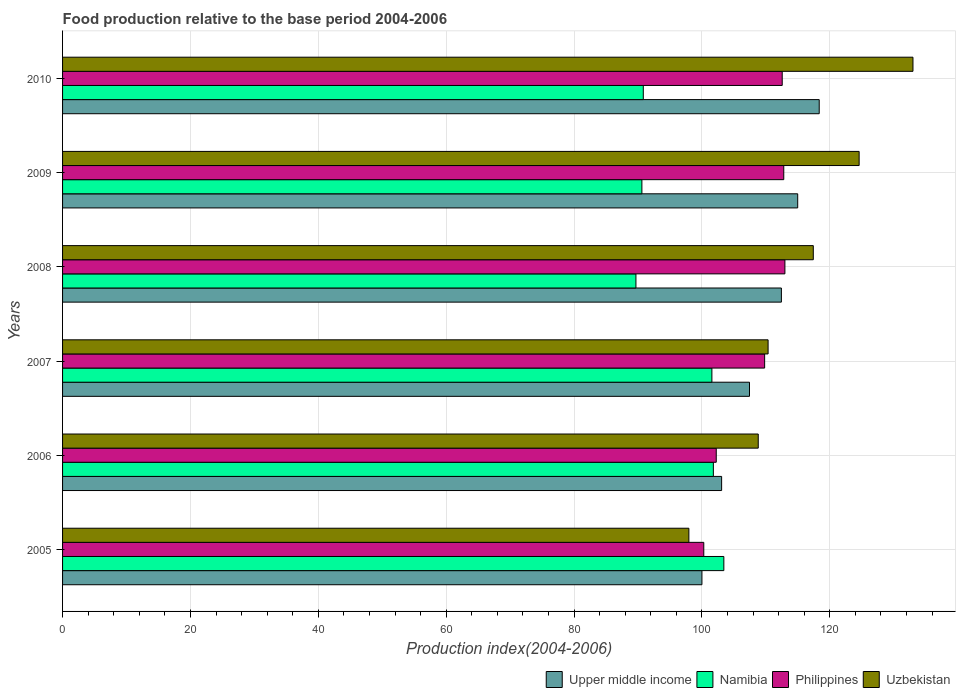How many groups of bars are there?
Make the answer very short. 6. Are the number of bars on each tick of the Y-axis equal?
Offer a terse response. Yes. How many bars are there on the 6th tick from the top?
Provide a short and direct response. 4. What is the food production index in Uzbekistan in 2009?
Provide a short and direct response. 124.59. Across all years, what is the maximum food production index in Philippines?
Your response must be concise. 112.98. Across all years, what is the minimum food production index in Philippines?
Offer a very short reply. 100.29. What is the total food production index in Upper middle income in the graph?
Offer a terse response. 656.28. What is the difference between the food production index in Upper middle income in 2005 and that in 2010?
Ensure brevity in your answer.  -18.35. What is the difference between the food production index in Upper middle income in 2006 and the food production index in Uzbekistan in 2010?
Provide a succinct answer. -29.93. What is the average food production index in Upper middle income per year?
Your answer should be very brief. 109.38. In the year 2010, what is the difference between the food production index in Uzbekistan and food production index in Namibia?
Provide a succinct answer. 42.18. What is the ratio of the food production index in Uzbekistan in 2006 to that in 2007?
Your response must be concise. 0.99. Is the food production index in Namibia in 2008 less than that in 2009?
Your answer should be compact. Yes. What is the difference between the highest and the second highest food production index in Upper middle income?
Your answer should be very brief. 3.37. What is the difference between the highest and the lowest food production index in Philippines?
Give a very brief answer. 12.69. In how many years, is the food production index in Upper middle income greater than the average food production index in Upper middle income taken over all years?
Provide a succinct answer. 3. What does the 3rd bar from the top in 2008 represents?
Provide a succinct answer. Namibia. What does the 4th bar from the bottom in 2009 represents?
Provide a succinct answer. Uzbekistan. How many bars are there?
Make the answer very short. 24. Are all the bars in the graph horizontal?
Offer a very short reply. Yes. What is the difference between two consecutive major ticks on the X-axis?
Give a very brief answer. 20. Are the values on the major ticks of X-axis written in scientific E-notation?
Ensure brevity in your answer.  No. Does the graph contain any zero values?
Your response must be concise. No. How are the legend labels stacked?
Offer a very short reply. Horizontal. What is the title of the graph?
Keep it short and to the point. Food production relative to the base period 2004-2006. Does "Chad" appear as one of the legend labels in the graph?
Provide a succinct answer. No. What is the label or title of the X-axis?
Provide a short and direct response. Production index(2004-2006). What is the label or title of the Y-axis?
Provide a short and direct response. Years. What is the Production index(2004-2006) in Upper middle income in 2005?
Your response must be concise. 100. What is the Production index(2004-2006) of Namibia in 2005?
Offer a very short reply. 103.43. What is the Production index(2004-2006) in Philippines in 2005?
Provide a short and direct response. 100.29. What is the Production index(2004-2006) of Uzbekistan in 2005?
Provide a succinct answer. 97.96. What is the Production index(2004-2006) of Upper middle income in 2006?
Keep it short and to the point. 103.08. What is the Production index(2004-2006) of Namibia in 2006?
Ensure brevity in your answer.  101.79. What is the Production index(2004-2006) in Philippines in 2006?
Your response must be concise. 102.24. What is the Production index(2004-2006) of Uzbekistan in 2006?
Give a very brief answer. 108.81. What is the Production index(2004-2006) in Upper middle income in 2007?
Your answer should be very brief. 107.44. What is the Production index(2004-2006) of Namibia in 2007?
Offer a terse response. 101.56. What is the Production index(2004-2006) of Philippines in 2007?
Your response must be concise. 109.81. What is the Production index(2004-2006) in Uzbekistan in 2007?
Your answer should be very brief. 110.35. What is the Production index(2004-2006) of Upper middle income in 2008?
Your answer should be compact. 112.43. What is the Production index(2004-2006) in Namibia in 2008?
Ensure brevity in your answer.  89.68. What is the Production index(2004-2006) of Philippines in 2008?
Provide a short and direct response. 112.98. What is the Production index(2004-2006) of Uzbekistan in 2008?
Give a very brief answer. 117.42. What is the Production index(2004-2006) of Upper middle income in 2009?
Make the answer very short. 114.98. What is the Production index(2004-2006) of Namibia in 2009?
Your answer should be very brief. 90.61. What is the Production index(2004-2006) in Philippines in 2009?
Make the answer very short. 112.8. What is the Production index(2004-2006) of Uzbekistan in 2009?
Offer a very short reply. 124.59. What is the Production index(2004-2006) of Upper middle income in 2010?
Provide a succinct answer. 118.35. What is the Production index(2004-2006) of Namibia in 2010?
Ensure brevity in your answer.  90.83. What is the Production index(2004-2006) in Philippines in 2010?
Your answer should be very brief. 112.56. What is the Production index(2004-2006) of Uzbekistan in 2010?
Your answer should be compact. 133.01. Across all years, what is the maximum Production index(2004-2006) of Upper middle income?
Provide a short and direct response. 118.35. Across all years, what is the maximum Production index(2004-2006) in Namibia?
Give a very brief answer. 103.43. Across all years, what is the maximum Production index(2004-2006) of Philippines?
Provide a short and direct response. 112.98. Across all years, what is the maximum Production index(2004-2006) of Uzbekistan?
Your response must be concise. 133.01. Across all years, what is the minimum Production index(2004-2006) in Upper middle income?
Provide a succinct answer. 100. Across all years, what is the minimum Production index(2004-2006) in Namibia?
Give a very brief answer. 89.68. Across all years, what is the minimum Production index(2004-2006) in Philippines?
Your response must be concise. 100.29. Across all years, what is the minimum Production index(2004-2006) in Uzbekistan?
Ensure brevity in your answer.  97.96. What is the total Production index(2004-2006) in Upper middle income in the graph?
Provide a succinct answer. 656.28. What is the total Production index(2004-2006) in Namibia in the graph?
Offer a very short reply. 577.9. What is the total Production index(2004-2006) of Philippines in the graph?
Offer a terse response. 650.68. What is the total Production index(2004-2006) of Uzbekistan in the graph?
Give a very brief answer. 692.14. What is the difference between the Production index(2004-2006) of Upper middle income in 2005 and that in 2006?
Your answer should be compact. -3.08. What is the difference between the Production index(2004-2006) of Namibia in 2005 and that in 2006?
Provide a short and direct response. 1.64. What is the difference between the Production index(2004-2006) of Philippines in 2005 and that in 2006?
Keep it short and to the point. -1.95. What is the difference between the Production index(2004-2006) of Uzbekistan in 2005 and that in 2006?
Give a very brief answer. -10.85. What is the difference between the Production index(2004-2006) in Upper middle income in 2005 and that in 2007?
Provide a short and direct response. -7.44. What is the difference between the Production index(2004-2006) of Namibia in 2005 and that in 2007?
Provide a succinct answer. 1.87. What is the difference between the Production index(2004-2006) of Philippines in 2005 and that in 2007?
Ensure brevity in your answer.  -9.52. What is the difference between the Production index(2004-2006) of Uzbekistan in 2005 and that in 2007?
Keep it short and to the point. -12.39. What is the difference between the Production index(2004-2006) of Upper middle income in 2005 and that in 2008?
Your response must be concise. -12.43. What is the difference between the Production index(2004-2006) of Namibia in 2005 and that in 2008?
Provide a short and direct response. 13.75. What is the difference between the Production index(2004-2006) of Philippines in 2005 and that in 2008?
Give a very brief answer. -12.69. What is the difference between the Production index(2004-2006) in Uzbekistan in 2005 and that in 2008?
Ensure brevity in your answer.  -19.46. What is the difference between the Production index(2004-2006) of Upper middle income in 2005 and that in 2009?
Provide a short and direct response. -14.98. What is the difference between the Production index(2004-2006) in Namibia in 2005 and that in 2009?
Make the answer very short. 12.82. What is the difference between the Production index(2004-2006) of Philippines in 2005 and that in 2009?
Keep it short and to the point. -12.51. What is the difference between the Production index(2004-2006) in Uzbekistan in 2005 and that in 2009?
Provide a succinct answer. -26.63. What is the difference between the Production index(2004-2006) of Upper middle income in 2005 and that in 2010?
Provide a succinct answer. -18.34. What is the difference between the Production index(2004-2006) of Philippines in 2005 and that in 2010?
Ensure brevity in your answer.  -12.27. What is the difference between the Production index(2004-2006) of Uzbekistan in 2005 and that in 2010?
Offer a terse response. -35.05. What is the difference between the Production index(2004-2006) of Upper middle income in 2006 and that in 2007?
Make the answer very short. -4.36. What is the difference between the Production index(2004-2006) in Namibia in 2006 and that in 2007?
Your answer should be very brief. 0.23. What is the difference between the Production index(2004-2006) of Philippines in 2006 and that in 2007?
Your response must be concise. -7.57. What is the difference between the Production index(2004-2006) of Uzbekistan in 2006 and that in 2007?
Your answer should be very brief. -1.54. What is the difference between the Production index(2004-2006) of Upper middle income in 2006 and that in 2008?
Your answer should be very brief. -9.35. What is the difference between the Production index(2004-2006) of Namibia in 2006 and that in 2008?
Give a very brief answer. 12.11. What is the difference between the Production index(2004-2006) of Philippines in 2006 and that in 2008?
Your answer should be compact. -10.74. What is the difference between the Production index(2004-2006) in Uzbekistan in 2006 and that in 2008?
Give a very brief answer. -8.61. What is the difference between the Production index(2004-2006) of Upper middle income in 2006 and that in 2009?
Your response must be concise. -11.9. What is the difference between the Production index(2004-2006) in Namibia in 2006 and that in 2009?
Your response must be concise. 11.18. What is the difference between the Production index(2004-2006) of Philippines in 2006 and that in 2009?
Keep it short and to the point. -10.56. What is the difference between the Production index(2004-2006) in Uzbekistan in 2006 and that in 2009?
Your answer should be very brief. -15.78. What is the difference between the Production index(2004-2006) in Upper middle income in 2006 and that in 2010?
Provide a short and direct response. -15.27. What is the difference between the Production index(2004-2006) in Namibia in 2006 and that in 2010?
Your answer should be very brief. 10.96. What is the difference between the Production index(2004-2006) in Philippines in 2006 and that in 2010?
Provide a succinct answer. -10.32. What is the difference between the Production index(2004-2006) of Uzbekistan in 2006 and that in 2010?
Your answer should be compact. -24.2. What is the difference between the Production index(2004-2006) in Upper middle income in 2007 and that in 2008?
Your answer should be very brief. -4.99. What is the difference between the Production index(2004-2006) in Namibia in 2007 and that in 2008?
Your response must be concise. 11.88. What is the difference between the Production index(2004-2006) in Philippines in 2007 and that in 2008?
Your answer should be very brief. -3.17. What is the difference between the Production index(2004-2006) of Uzbekistan in 2007 and that in 2008?
Your answer should be compact. -7.07. What is the difference between the Production index(2004-2006) of Upper middle income in 2007 and that in 2009?
Offer a very short reply. -7.54. What is the difference between the Production index(2004-2006) in Namibia in 2007 and that in 2009?
Your answer should be very brief. 10.95. What is the difference between the Production index(2004-2006) in Philippines in 2007 and that in 2009?
Ensure brevity in your answer.  -2.99. What is the difference between the Production index(2004-2006) in Uzbekistan in 2007 and that in 2009?
Ensure brevity in your answer.  -14.24. What is the difference between the Production index(2004-2006) of Upper middle income in 2007 and that in 2010?
Ensure brevity in your answer.  -10.91. What is the difference between the Production index(2004-2006) of Namibia in 2007 and that in 2010?
Provide a short and direct response. 10.73. What is the difference between the Production index(2004-2006) of Philippines in 2007 and that in 2010?
Your answer should be compact. -2.75. What is the difference between the Production index(2004-2006) in Uzbekistan in 2007 and that in 2010?
Your response must be concise. -22.66. What is the difference between the Production index(2004-2006) in Upper middle income in 2008 and that in 2009?
Make the answer very short. -2.55. What is the difference between the Production index(2004-2006) of Namibia in 2008 and that in 2009?
Make the answer very short. -0.93. What is the difference between the Production index(2004-2006) in Philippines in 2008 and that in 2009?
Give a very brief answer. 0.18. What is the difference between the Production index(2004-2006) in Uzbekistan in 2008 and that in 2009?
Make the answer very short. -7.17. What is the difference between the Production index(2004-2006) of Upper middle income in 2008 and that in 2010?
Provide a succinct answer. -5.92. What is the difference between the Production index(2004-2006) of Namibia in 2008 and that in 2010?
Give a very brief answer. -1.15. What is the difference between the Production index(2004-2006) of Philippines in 2008 and that in 2010?
Provide a short and direct response. 0.42. What is the difference between the Production index(2004-2006) of Uzbekistan in 2008 and that in 2010?
Offer a terse response. -15.59. What is the difference between the Production index(2004-2006) of Upper middle income in 2009 and that in 2010?
Provide a short and direct response. -3.37. What is the difference between the Production index(2004-2006) in Namibia in 2009 and that in 2010?
Keep it short and to the point. -0.22. What is the difference between the Production index(2004-2006) in Philippines in 2009 and that in 2010?
Your answer should be compact. 0.24. What is the difference between the Production index(2004-2006) in Uzbekistan in 2009 and that in 2010?
Make the answer very short. -8.42. What is the difference between the Production index(2004-2006) of Upper middle income in 2005 and the Production index(2004-2006) of Namibia in 2006?
Keep it short and to the point. -1.79. What is the difference between the Production index(2004-2006) in Upper middle income in 2005 and the Production index(2004-2006) in Philippines in 2006?
Ensure brevity in your answer.  -2.24. What is the difference between the Production index(2004-2006) of Upper middle income in 2005 and the Production index(2004-2006) of Uzbekistan in 2006?
Provide a succinct answer. -8.81. What is the difference between the Production index(2004-2006) in Namibia in 2005 and the Production index(2004-2006) in Philippines in 2006?
Provide a short and direct response. 1.19. What is the difference between the Production index(2004-2006) in Namibia in 2005 and the Production index(2004-2006) in Uzbekistan in 2006?
Offer a very short reply. -5.38. What is the difference between the Production index(2004-2006) of Philippines in 2005 and the Production index(2004-2006) of Uzbekistan in 2006?
Keep it short and to the point. -8.52. What is the difference between the Production index(2004-2006) in Upper middle income in 2005 and the Production index(2004-2006) in Namibia in 2007?
Provide a succinct answer. -1.56. What is the difference between the Production index(2004-2006) in Upper middle income in 2005 and the Production index(2004-2006) in Philippines in 2007?
Give a very brief answer. -9.81. What is the difference between the Production index(2004-2006) in Upper middle income in 2005 and the Production index(2004-2006) in Uzbekistan in 2007?
Keep it short and to the point. -10.35. What is the difference between the Production index(2004-2006) in Namibia in 2005 and the Production index(2004-2006) in Philippines in 2007?
Provide a succinct answer. -6.38. What is the difference between the Production index(2004-2006) of Namibia in 2005 and the Production index(2004-2006) of Uzbekistan in 2007?
Provide a succinct answer. -6.92. What is the difference between the Production index(2004-2006) of Philippines in 2005 and the Production index(2004-2006) of Uzbekistan in 2007?
Make the answer very short. -10.06. What is the difference between the Production index(2004-2006) of Upper middle income in 2005 and the Production index(2004-2006) of Namibia in 2008?
Provide a succinct answer. 10.32. What is the difference between the Production index(2004-2006) of Upper middle income in 2005 and the Production index(2004-2006) of Philippines in 2008?
Make the answer very short. -12.98. What is the difference between the Production index(2004-2006) in Upper middle income in 2005 and the Production index(2004-2006) in Uzbekistan in 2008?
Your response must be concise. -17.42. What is the difference between the Production index(2004-2006) of Namibia in 2005 and the Production index(2004-2006) of Philippines in 2008?
Your answer should be very brief. -9.55. What is the difference between the Production index(2004-2006) of Namibia in 2005 and the Production index(2004-2006) of Uzbekistan in 2008?
Give a very brief answer. -13.99. What is the difference between the Production index(2004-2006) in Philippines in 2005 and the Production index(2004-2006) in Uzbekistan in 2008?
Keep it short and to the point. -17.13. What is the difference between the Production index(2004-2006) of Upper middle income in 2005 and the Production index(2004-2006) of Namibia in 2009?
Your answer should be very brief. 9.39. What is the difference between the Production index(2004-2006) of Upper middle income in 2005 and the Production index(2004-2006) of Philippines in 2009?
Make the answer very short. -12.8. What is the difference between the Production index(2004-2006) in Upper middle income in 2005 and the Production index(2004-2006) in Uzbekistan in 2009?
Offer a terse response. -24.59. What is the difference between the Production index(2004-2006) in Namibia in 2005 and the Production index(2004-2006) in Philippines in 2009?
Keep it short and to the point. -9.37. What is the difference between the Production index(2004-2006) in Namibia in 2005 and the Production index(2004-2006) in Uzbekistan in 2009?
Give a very brief answer. -21.16. What is the difference between the Production index(2004-2006) of Philippines in 2005 and the Production index(2004-2006) of Uzbekistan in 2009?
Give a very brief answer. -24.3. What is the difference between the Production index(2004-2006) of Upper middle income in 2005 and the Production index(2004-2006) of Namibia in 2010?
Your answer should be compact. 9.17. What is the difference between the Production index(2004-2006) of Upper middle income in 2005 and the Production index(2004-2006) of Philippines in 2010?
Your answer should be compact. -12.56. What is the difference between the Production index(2004-2006) of Upper middle income in 2005 and the Production index(2004-2006) of Uzbekistan in 2010?
Your answer should be very brief. -33.01. What is the difference between the Production index(2004-2006) in Namibia in 2005 and the Production index(2004-2006) in Philippines in 2010?
Offer a very short reply. -9.13. What is the difference between the Production index(2004-2006) in Namibia in 2005 and the Production index(2004-2006) in Uzbekistan in 2010?
Provide a short and direct response. -29.58. What is the difference between the Production index(2004-2006) in Philippines in 2005 and the Production index(2004-2006) in Uzbekistan in 2010?
Provide a short and direct response. -32.72. What is the difference between the Production index(2004-2006) in Upper middle income in 2006 and the Production index(2004-2006) in Namibia in 2007?
Offer a terse response. 1.52. What is the difference between the Production index(2004-2006) in Upper middle income in 2006 and the Production index(2004-2006) in Philippines in 2007?
Make the answer very short. -6.73. What is the difference between the Production index(2004-2006) of Upper middle income in 2006 and the Production index(2004-2006) of Uzbekistan in 2007?
Offer a terse response. -7.27. What is the difference between the Production index(2004-2006) in Namibia in 2006 and the Production index(2004-2006) in Philippines in 2007?
Provide a short and direct response. -8.02. What is the difference between the Production index(2004-2006) of Namibia in 2006 and the Production index(2004-2006) of Uzbekistan in 2007?
Give a very brief answer. -8.56. What is the difference between the Production index(2004-2006) of Philippines in 2006 and the Production index(2004-2006) of Uzbekistan in 2007?
Provide a short and direct response. -8.11. What is the difference between the Production index(2004-2006) in Upper middle income in 2006 and the Production index(2004-2006) in Namibia in 2008?
Make the answer very short. 13.4. What is the difference between the Production index(2004-2006) in Upper middle income in 2006 and the Production index(2004-2006) in Philippines in 2008?
Your answer should be very brief. -9.9. What is the difference between the Production index(2004-2006) of Upper middle income in 2006 and the Production index(2004-2006) of Uzbekistan in 2008?
Offer a terse response. -14.34. What is the difference between the Production index(2004-2006) of Namibia in 2006 and the Production index(2004-2006) of Philippines in 2008?
Offer a terse response. -11.19. What is the difference between the Production index(2004-2006) of Namibia in 2006 and the Production index(2004-2006) of Uzbekistan in 2008?
Provide a short and direct response. -15.63. What is the difference between the Production index(2004-2006) in Philippines in 2006 and the Production index(2004-2006) in Uzbekistan in 2008?
Offer a terse response. -15.18. What is the difference between the Production index(2004-2006) of Upper middle income in 2006 and the Production index(2004-2006) of Namibia in 2009?
Give a very brief answer. 12.47. What is the difference between the Production index(2004-2006) of Upper middle income in 2006 and the Production index(2004-2006) of Philippines in 2009?
Your answer should be compact. -9.72. What is the difference between the Production index(2004-2006) in Upper middle income in 2006 and the Production index(2004-2006) in Uzbekistan in 2009?
Make the answer very short. -21.51. What is the difference between the Production index(2004-2006) in Namibia in 2006 and the Production index(2004-2006) in Philippines in 2009?
Ensure brevity in your answer.  -11.01. What is the difference between the Production index(2004-2006) of Namibia in 2006 and the Production index(2004-2006) of Uzbekistan in 2009?
Offer a terse response. -22.8. What is the difference between the Production index(2004-2006) in Philippines in 2006 and the Production index(2004-2006) in Uzbekistan in 2009?
Make the answer very short. -22.35. What is the difference between the Production index(2004-2006) of Upper middle income in 2006 and the Production index(2004-2006) of Namibia in 2010?
Give a very brief answer. 12.25. What is the difference between the Production index(2004-2006) in Upper middle income in 2006 and the Production index(2004-2006) in Philippines in 2010?
Your response must be concise. -9.48. What is the difference between the Production index(2004-2006) in Upper middle income in 2006 and the Production index(2004-2006) in Uzbekistan in 2010?
Make the answer very short. -29.93. What is the difference between the Production index(2004-2006) in Namibia in 2006 and the Production index(2004-2006) in Philippines in 2010?
Offer a very short reply. -10.77. What is the difference between the Production index(2004-2006) of Namibia in 2006 and the Production index(2004-2006) of Uzbekistan in 2010?
Provide a succinct answer. -31.22. What is the difference between the Production index(2004-2006) of Philippines in 2006 and the Production index(2004-2006) of Uzbekistan in 2010?
Give a very brief answer. -30.77. What is the difference between the Production index(2004-2006) of Upper middle income in 2007 and the Production index(2004-2006) of Namibia in 2008?
Provide a succinct answer. 17.76. What is the difference between the Production index(2004-2006) in Upper middle income in 2007 and the Production index(2004-2006) in Philippines in 2008?
Your answer should be very brief. -5.54. What is the difference between the Production index(2004-2006) of Upper middle income in 2007 and the Production index(2004-2006) of Uzbekistan in 2008?
Make the answer very short. -9.98. What is the difference between the Production index(2004-2006) in Namibia in 2007 and the Production index(2004-2006) in Philippines in 2008?
Provide a short and direct response. -11.42. What is the difference between the Production index(2004-2006) in Namibia in 2007 and the Production index(2004-2006) in Uzbekistan in 2008?
Offer a very short reply. -15.86. What is the difference between the Production index(2004-2006) of Philippines in 2007 and the Production index(2004-2006) of Uzbekistan in 2008?
Make the answer very short. -7.61. What is the difference between the Production index(2004-2006) of Upper middle income in 2007 and the Production index(2004-2006) of Namibia in 2009?
Provide a succinct answer. 16.83. What is the difference between the Production index(2004-2006) of Upper middle income in 2007 and the Production index(2004-2006) of Philippines in 2009?
Offer a terse response. -5.36. What is the difference between the Production index(2004-2006) in Upper middle income in 2007 and the Production index(2004-2006) in Uzbekistan in 2009?
Your answer should be compact. -17.15. What is the difference between the Production index(2004-2006) in Namibia in 2007 and the Production index(2004-2006) in Philippines in 2009?
Your response must be concise. -11.24. What is the difference between the Production index(2004-2006) in Namibia in 2007 and the Production index(2004-2006) in Uzbekistan in 2009?
Your answer should be compact. -23.03. What is the difference between the Production index(2004-2006) of Philippines in 2007 and the Production index(2004-2006) of Uzbekistan in 2009?
Provide a succinct answer. -14.78. What is the difference between the Production index(2004-2006) in Upper middle income in 2007 and the Production index(2004-2006) in Namibia in 2010?
Your answer should be compact. 16.61. What is the difference between the Production index(2004-2006) in Upper middle income in 2007 and the Production index(2004-2006) in Philippines in 2010?
Make the answer very short. -5.12. What is the difference between the Production index(2004-2006) of Upper middle income in 2007 and the Production index(2004-2006) of Uzbekistan in 2010?
Give a very brief answer. -25.57. What is the difference between the Production index(2004-2006) in Namibia in 2007 and the Production index(2004-2006) in Philippines in 2010?
Keep it short and to the point. -11. What is the difference between the Production index(2004-2006) of Namibia in 2007 and the Production index(2004-2006) of Uzbekistan in 2010?
Provide a succinct answer. -31.45. What is the difference between the Production index(2004-2006) in Philippines in 2007 and the Production index(2004-2006) in Uzbekistan in 2010?
Offer a very short reply. -23.2. What is the difference between the Production index(2004-2006) of Upper middle income in 2008 and the Production index(2004-2006) of Namibia in 2009?
Your answer should be compact. 21.82. What is the difference between the Production index(2004-2006) of Upper middle income in 2008 and the Production index(2004-2006) of Philippines in 2009?
Make the answer very short. -0.37. What is the difference between the Production index(2004-2006) in Upper middle income in 2008 and the Production index(2004-2006) in Uzbekistan in 2009?
Your answer should be very brief. -12.16. What is the difference between the Production index(2004-2006) of Namibia in 2008 and the Production index(2004-2006) of Philippines in 2009?
Your response must be concise. -23.12. What is the difference between the Production index(2004-2006) of Namibia in 2008 and the Production index(2004-2006) of Uzbekistan in 2009?
Offer a terse response. -34.91. What is the difference between the Production index(2004-2006) in Philippines in 2008 and the Production index(2004-2006) in Uzbekistan in 2009?
Give a very brief answer. -11.61. What is the difference between the Production index(2004-2006) in Upper middle income in 2008 and the Production index(2004-2006) in Namibia in 2010?
Offer a very short reply. 21.6. What is the difference between the Production index(2004-2006) of Upper middle income in 2008 and the Production index(2004-2006) of Philippines in 2010?
Offer a very short reply. -0.13. What is the difference between the Production index(2004-2006) in Upper middle income in 2008 and the Production index(2004-2006) in Uzbekistan in 2010?
Ensure brevity in your answer.  -20.58. What is the difference between the Production index(2004-2006) in Namibia in 2008 and the Production index(2004-2006) in Philippines in 2010?
Provide a succinct answer. -22.88. What is the difference between the Production index(2004-2006) of Namibia in 2008 and the Production index(2004-2006) of Uzbekistan in 2010?
Keep it short and to the point. -43.33. What is the difference between the Production index(2004-2006) of Philippines in 2008 and the Production index(2004-2006) of Uzbekistan in 2010?
Offer a very short reply. -20.03. What is the difference between the Production index(2004-2006) of Upper middle income in 2009 and the Production index(2004-2006) of Namibia in 2010?
Your response must be concise. 24.15. What is the difference between the Production index(2004-2006) of Upper middle income in 2009 and the Production index(2004-2006) of Philippines in 2010?
Your answer should be compact. 2.42. What is the difference between the Production index(2004-2006) in Upper middle income in 2009 and the Production index(2004-2006) in Uzbekistan in 2010?
Your answer should be very brief. -18.03. What is the difference between the Production index(2004-2006) in Namibia in 2009 and the Production index(2004-2006) in Philippines in 2010?
Offer a terse response. -21.95. What is the difference between the Production index(2004-2006) of Namibia in 2009 and the Production index(2004-2006) of Uzbekistan in 2010?
Your answer should be compact. -42.4. What is the difference between the Production index(2004-2006) in Philippines in 2009 and the Production index(2004-2006) in Uzbekistan in 2010?
Make the answer very short. -20.21. What is the average Production index(2004-2006) in Upper middle income per year?
Provide a succinct answer. 109.38. What is the average Production index(2004-2006) in Namibia per year?
Your answer should be compact. 96.32. What is the average Production index(2004-2006) of Philippines per year?
Give a very brief answer. 108.45. What is the average Production index(2004-2006) in Uzbekistan per year?
Provide a succinct answer. 115.36. In the year 2005, what is the difference between the Production index(2004-2006) of Upper middle income and Production index(2004-2006) of Namibia?
Your answer should be very brief. -3.43. In the year 2005, what is the difference between the Production index(2004-2006) in Upper middle income and Production index(2004-2006) in Philippines?
Your answer should be compact. -0.29. In the year 2005, what is the difference between the Production index(2004-2006) in Upper middle income and Production index(2004-2006) in Uzbekistan?
Ensure brevity in your answer.  2.04. In the year 2005, what is the difference between the Production index(2004-2006) in Namibia and Production index(2004-2006) in Philippines?
Keep it short and to the point. 3.14. In the year 2005, what is the difference between the Production index(2004-2006) of Namibia and Production index(2004-2006) of Uzbekistan?
Provide a short and direct response. 5.47. In the year 2005, what is the difference between the Production index(2004-2006) of Philippines and Production index(2004-2006) of Uzbekistan?
Your answer should be very brief. 2.33. In the year 2006, what is the difference between the Production index(2004-2006) in Upper middle income and Production index(2004-2006) in Namibia?
Offer a very short reply. 1.29. In the year 2006, what is the difference between the Production index(2004-2006) in Upper middle income and Production index(2004-2006) in Philippines?
Make the answer very short. 0.84. In the year 2006, what is the difference between the Production index(2004-2006) in Upper middle income and Production index(2004-2006) in Uzbekistan?
Provide a short and direct response. -5.73. In the year 2006, what is the difference between the Production index(2004-2006) in Namibia and Production index(2004-2006) in Philippines?
Offer a very short reply. -0.45. In the year 2006, what is the difference between the Production index(2004-2006) in Namibia and Production index(2004-2006) in Uzbekistan?
Keep it short and to the point. -7.02. In the year 2006, what is the difference between the Production index(2004-2006) in Philippines and Production index(2004-2006) in Uzbekistan?
Offer a terse response. -6.57. In the year 2007, what is the difference between the Production index(2004-2006) of Upper middle income and Production index(2004-2006) of Namibia?
Offer a very short reply. 5.88. In the year 2007, what is the difference between the Production index(2004-2006) in Upper middle income and Production index(2004-2006) in Philippines?
Provide a short and direct response. -2.37. In the year 2007, what is the difference between the Production index(2004-2006) of Upper middle income and Production index(2004-2006) of Uzbekistan?
Give a very brief answer. -2.91. In the year 2007, what is the difference between the Production index(2004-2006) of Namibia and Production index(2004-2006) of Philippines?
Your answer should be very brief. -8.25. In the year 2007, what is the difference between the Production index(2004-2006) in Namibia and Production index(2004-2006) in Uzbekistan?
Provide a succinct answer. -8.79. In the year 2007, what is the difference between the Production index(2004-2006) in Philippines and Production index(2004-2006) in Uzbekistan?
Provide a succinct answer. -0.54. In the year 2008, what is the difference between the Production index(2004-2006) of Upper middle income and Production index(2004-2006) of Namibia?
Keep it short and to the point. 22.75. In the year 2008, what is the difference between the Production index(2004-2006) in Upper middle income and Production index(2004-2006) in Philippines?
Make the answer very short. -0.55. In the year 2008, what is the difference between the Production index(2004-2006) of Upper middle income and Production index(2004-2006) of Uzbekistan?
Your answer should be compact. -4.99. In the year 2008, what is the difference between the Production index(2004-2006) of Namibia and Production index(2004-2006) of Philippines?
Make the answer very short. -23.3. In the year 2008, what is the difference between the Production index(2004-2006) of Namibia and Production index(2004-2006) of Uzbekistan?
Offer a terse response. -27.74. In the year 2008, what is the difference between the Production index(2004-2006) of Philippines and Production index(2004-2006) of Uzbekistan?
Give a very brief answer. -4.44. In the year 2009, what is the difference between the Production index(2004-2006) in Upper middle income and Production index(2004-2006) in Namibia?
Make the answer very short. 24.37. In the year 2009, what is the difference between the Production index(2004-2006) of Upper middle income and Production index(2004-2006) of Philippines?
Provide a succinct answer. 2.18. In the year 2009, what is the difference between the Production index(2004-2006) in Upper middle income and Production index(2004-2006) in Uzbekistan?
Keep it short and to the point. -9.61. In the year 2009, what is the difference between the Production index(2004-2006) of Namibia and Production index(2004-2006) of Philippines?
Offer a terse response. -22.19. In the year 2009, what is the difference between the Production index(2004-2006) of Namibia and Production index(2004-2006) of Uzbekistan?
Ensure brevity in your answer.  -33.98. In the year 2009, what is the difference between the Production index(2004-2006) in Philippines and Production index(2004-2006) in Uzbekistan?
Give a very brief answer. -11.79. In the year 2010, what is the difference between the Production index(2004-2006) of Upper middle income and Production index(2004-2006) of Namibia?
Your answer should be compact. 27.52. In the year 2010, what is the difference between the Production index(2004-2006) of Upper middle income and Production index(2004-2006) of Philippines?
Offer a very short reply. 5.79. In the year 2010, what is the difference between the Production index(2004-2006) in Upper middle income and Production index(2004-2006) in Uzbekistan?
Offer a very short reply. -14.66. In the year 2010, what is the difference between the Production index(2004-2006) in Namibia and Production index(2004-2006) in Philippines?
Your answer should be compact. -21.73. In the year 2010, what is the difference between the Production index(2004-2006) in Namibia and Production index(2004-2006) in Uzbekistan?
Make the answer very short. -42.18. In the year 2010, what is the difference between the Production index(2004-2006) in Philippines and Production index(2004-2006) in Uzbekistan?
Make the answer very short. -20.45. What is the ratio of the Production index(2004-2006) of Upper middle income in 2005 to that in 2006?
Provide a short and direct response. 0.97. What is the ratio of the Production index(2004-2006) in Namibia in 2005 to that in 2006?
Your answer should be compact. 1.02. What is the ratio of the Production index(2004-2006) of Philippines in 2005 to that in 2006?
Your answer should be very brief. 0.98. What is the ratio of the Production index(2004-2006) in Uzbekistan in 2005 to that in 2006?
Keep it short and to the point. 0.9. What is the ratio of the Production index(2004-2006) of Upper middle income in 2005 to that in 2007?
Provide a succinct answer. 0.93. What is the ratio of the Production index(2004-2006) of Namibia in 2005 to that in 2007?
Your answer should be compact. 1.02. What is the ratio of the Production index(2004-2006) in Philippines in 2005 to that in 2007?
Your answer should be compact. 0.91. What is the ratio of the Production index(2004-2006) in Uzbekistan in 2005 to that in 2007?
Your answer should be compact. 0.89. What is the ratio of the Production index(2004-2006) of Upper middle income in 2005 to that in 2008?
Your answer should be compact. 0.89. What is the ratio of the Production index(2004-2006) of Namibia in 2005 to that in 2008?
Your answer should be compact. 1.15. What is the ratio of the Production index(2004-2006) of Philippines in 2005 to that in 2008?
Offer a very short reply. 0.89. What is the ratio of the Production index(2004-2006) in Uzbekistan in 2005 to that in 2008?
Your response must be concise. 0.83. What is the ratio of the Production index(2004-2006) in Upper middle income in 2005 to that in 2009?
Give a very brief answer. 0.87. What is the ratio of the Production index(2004-2006) of Namibia in 2005 to that in 2009?
Make the answer very short. 1.14. What is the ratio of the Production index(2004-2006) of Philippines in 2005 to that in 2009?
Your answer should be very brief. 0.89. What is the ratio of the Production index(2004-2006) of Uzbekistan in 2005 to that in 2009?
Your answer should be compact. 0.79. What is the ratio of the Production index(2004-2006) of Upper middle income in 2005 to that in 2010?
Your response must be concise. 0.84. What is the ratio of the Production index(2004-2006) of Namibia in 2005 to that in 2010?
Offer a very short reply. 1.14. What is the ratio of the Production index(2004-2006) in Philippines in 2005 to that in 2010?
Provide a succinct answer. 0.89. What is the ratio of the Production index(2004-2006) of Uzbekistan in 2005 to that in 2010?
Give a very brief answer. 0.74. What is the ratio of the Production index(2004-2006) in Upper middle income in 2006 to that in 2007?
Ensure brevity in your answer.  0.96. What is the ratio of the Production index(2004-2006) of Namibia in 2006 to that in 2007?
Provide a succinct answer. 1. What is the ratio of the Production index(2004-2006) in Philippines in 2006 to that in 2007?
Provide a succinct answer. 0.93. What is the ratio of the Production index(2004-2006) of Upper middle income in 2006 to that in 2008?
Your answer should be compact. 0.92. What is the ratio of the Production index(2004-2006) in Namibia in 2006 to that in 2008?
Make the answer very short. 1.14. What is the ratio of the Production index(2004-2006) in Philippines in 2006 to that in 2008?
Offer a very short reply. 0.9. What is the ratio of the Production index(2004-2006) in Uzbekistan in 2006 to that in 2008?
Give a very brief answer. 0.93. What is the ratio of the Production index(2004-2006) in Upper middle income in 2006 to that in 2009?
Make the answer very short. 0.9. What is the ratio of the Production index(2004-2006) of Namibia in 2006 to that in 2009?
Offer a very short reply. 1.12. What is the ratio of the Production index(2004-2006) in Philippines in 2006 to that in 2009?
Provide a short and direct response. 0.91. What is the ratio of the Production index(2004-2006) in Uzbekistan in 2006 to that in 2009?
Offer a terse response. 0.87. What is the ratio of the Production index(2004-2006) of Upper middle income in 2006 to that in 2010?
Provide a short and direct response. 0.87. What is the ratio of the Production index(2004-2006) in Namibia in 2006 to that in 2010?
Provide a short and direct response. 1.12. What is the ratio of the Production index(2004-2006) in Philippines in 2006 to that in 2010?
Your response must be concise. 0.91. What is the ratio of the Production index(2004-2006) of Uzbekistan in 2006 to that in 2010?
Keep it short and to the point. 0.82. What is the ratio of the Production index(2004-2006) of Upper middle income in 2007 to that in 2008?
Keep it short and to the point. 0.96. What is the ratio of the Production index(2004-2006) of Namibia in 2007 to that in 2008?
Keep it short and to the point. 1.13. What is the ratio of the Production index(2004-2006) of Philippines in 2007 to that in 2008?
Your response must be concise. 0.97. What is the ratio of the Production index(2004-2006) of Uzbekistan in 2007 to that in 2008?
Give a very brief answer. 0.94. What is the ratio of the Production index(2004-2006) in Upper middle income in 2007 to that in 2009?
Keep it short and to the point. 0.93. What is the ratio of the Production index(2004-2006) in Namibia in 2007 to that in 2009?
Keep it short and to the point. 1.12. What is the ratio of the Production index(2004-2006) of Philippines in 2007 to that in 2009?
Ensure brevity in your answer.  0.97. What is the ratio of the Production index(2004-2006) of Uzbekistan in 2007 to that in 2009?
Your response must be concise. 0.89. What is the ratio of the Production index(2004-2006) of Upper middle income in 2007 to that in 2010?
Provide a short and direct response. 0.91. What is the ratio of the Production index(2004-2006) in Namibia in 2007 to that in 2010?
Provide a succinct answer. 1.12. What is the ratio of the Production index(2004-2006) in Philippines in 2007 to that in 2010?
Your answer should be very brief. 0.98. What is the ratio of the Production index(2004-2006) of Uzbekistan in 2007 to that in 2010?
Make the answer very short. 0.83. What is the ratio of the Production index(2004-2006) of Upper middle income in 2008 to that in 2009?
Offer a terse response. 0.98. What is the ratio of the Production index(2004-2006) of Uzbekistan in 2008 to that in 2009?
Provide a short and direct response. 0.94. What is the ratio of the Production index(2004-2006) of Upper middle income in 2008 to that in 2010?
Your response must be concise. 0.95. What is the ratio of the Production index(2004-2006) in Namibia in 2008 to that in 2010?
Your response must be concise. 0.99. What is the ratio of the Production index(2004-2006) in Philippines in 2008 to that in 2010?
Your answer should be compact. 1. What is the ratio of the Production index(2004-2006) of Uzbekistan in 2008 to that in 2010?
Provide a short and direct response. 0.88. What is the ratio of the Production index(2004-2006) of Upper middle income in 2009 to that in 2010?
Give a very brief answer. 0.97. What is the ratio of the Production index(2004-2006) in Namibia in 2009 to that in 2010?
Give a very brief answer. 1. What is the ratio of the Production index(2004-2006) in Philippines in 2009 to that in 2010?
Ensure brevity in your answer.  1. What is the ratio of the Production index(2004-2006) of Uzbekistan in 2009 to that in 2010?
Give a very brief answer. 0.94. What is the difference between the highest and the second highest Production index(2004-2006) in Upper middle income?
Ensure brevity in your answer.  3.37. What is the difference between the highest and the second highest Production index(2004-2006) of Namibia?
Ensure brevity in your answer.  1.64. What is the difference between the highest and the second highest Production index(2004-2006) of Philippines?
Make the answer very short. 0.18. What is the difference between the highest and the second highest Production index(2004-2006) in Uzbekistan?
Provide a short and direct response. 8.42. What is the difference between the highest and the lowest Production index(2004-2006) in Upper middle income?
Offer a very short reply. 18.34. What is the difference between the highest and the lowest Production index(2004-2006) in Namibia?
Offer a terse response. 13.75. What is the difference between the highest and the lowest Production index(2004-2006) in Philippines?
Ensure brevity in your answer.  12.69. What is the difference between the highest and the lowest Production index(2004-2006) of Uzbekistan?
Offer a terse response. 35.05. 